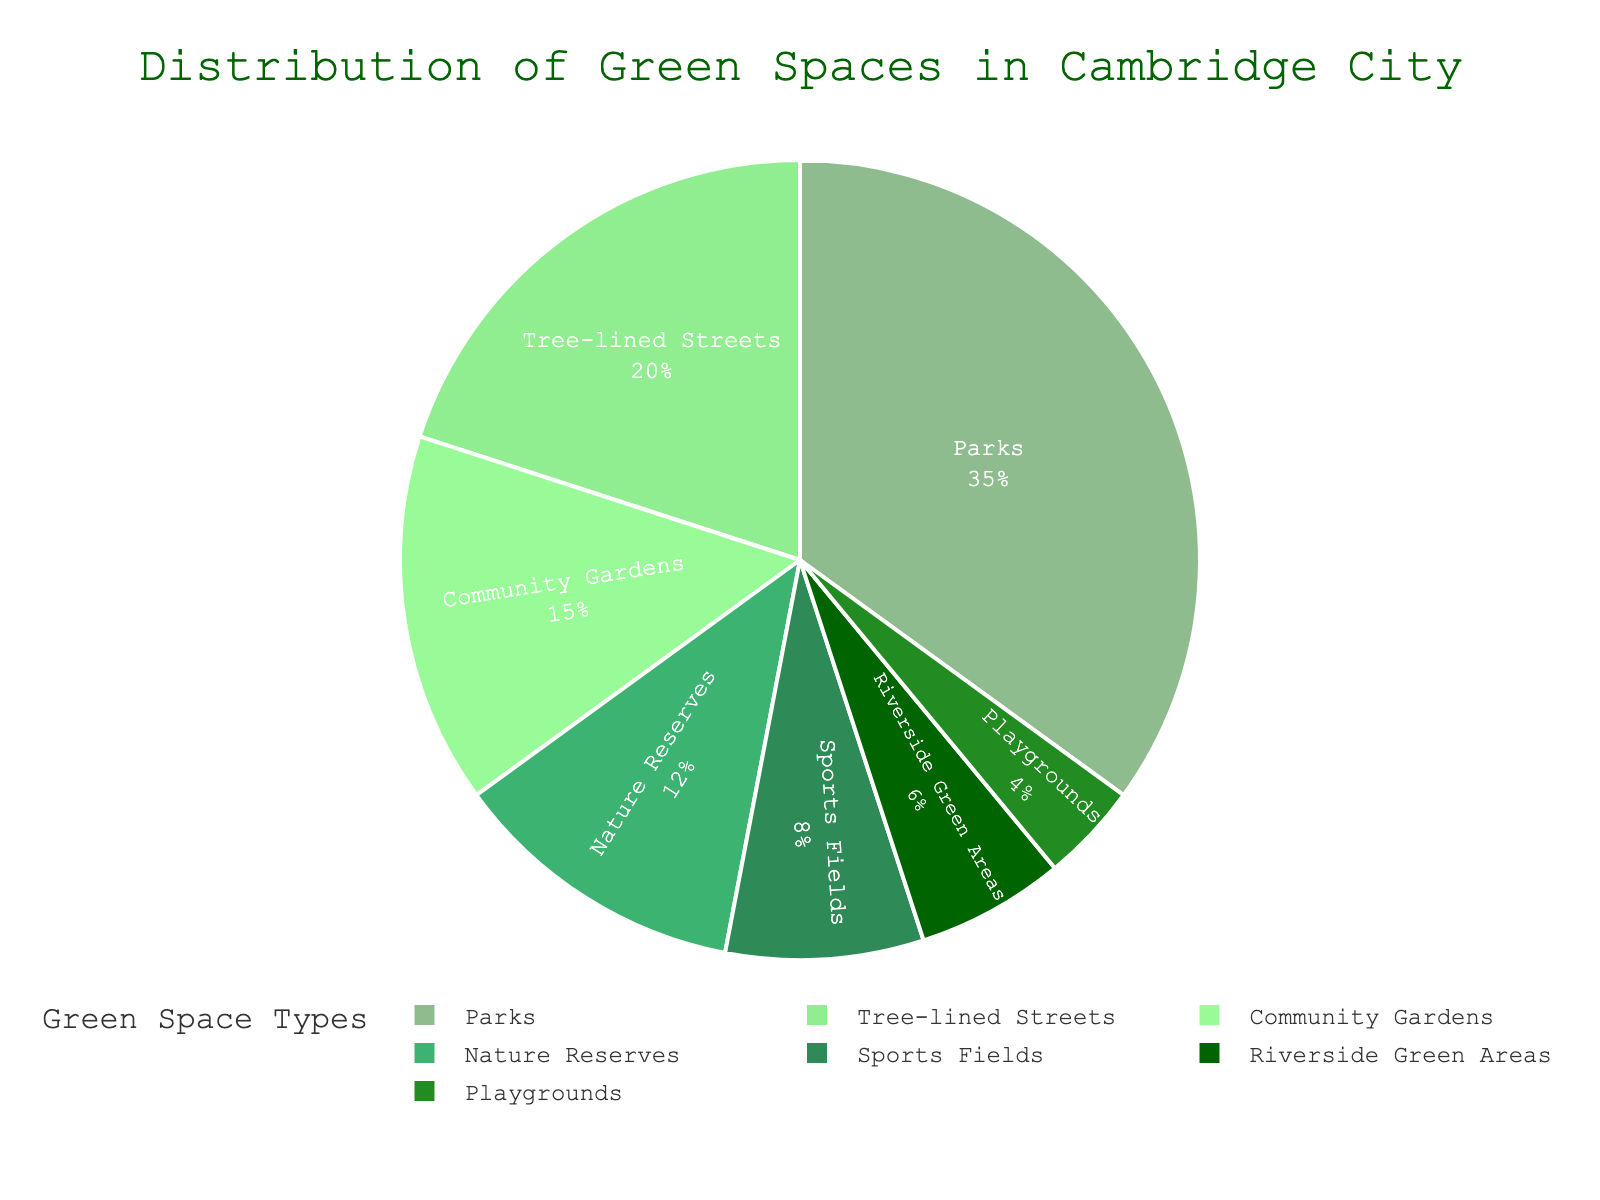What type of green space occupies the largest percentage in Cambridge City? The type that occupies the largest percentage is the one with the highest value in the pie chart. From the data, Parks occupy 35%, which is the largest.
Answer: Parks Which green space type has a higher percentage, sports fields or playgrounds? Compare the percentages of sports fields and playgrounds. Sports fields occupy 8%, while playgrounds occupy 4%. Since 8% is greater than 4%, sports fields have a higher percentage.
Answer: Sports fields Are community gardens and nature reserves collectively occupying more or less than 30%? Add the percentages of community gardens (15%) and nature reserves (12%) to get the total. 15% + 12% = 27%, which is less than 30%.
Answer: Less How much larger is the percentage of tree-lined streets compared to riverside green areas? Subtract the percentage of riverside green areas (6%) from the percentage of tree-lined streets (20%). 20% - 6% = 14%.
Answer: 14% What percentage of green spaces is dedicated to playgrounds and riverside green areas combined? Add the percentages of playgrounds (4%) and riverside green areas (6%). 4% + 6% = 10%.
Answer: 10% Which category occupies the third-largest percentage of green spaces in Cambridge City? List the percentages in descending order: Parks (35%), Tree-lined Streets (20%), Community Gardens (15%), Nature Reserves (12%), etc. The third-largest percentage is for Community Gardens at 15%.
Answer: Community Gardens Do sports fields and nature reserves together occupy a higher percentage than parks? Add the percentages of sports fields (8%) and nature reserves (12%), which gives 8% + 12% = 20%. Compare this to the percentage of parks (35%). Since 20% is less than 35%, they occupy a lower percentage than parks.
Answer: No How many types of green spaces occupy 10% or more individually? Identify the types with percentages 10% or more: Parks (35%), Community Gardens (15%), Tree-lined Streets (20%), and Nature Reserves (12%). Count them to get the total: 4 types.
Answer: 4 What color is used to represent community gardens in the chart? Identify the color associated with community gardens. According to the color palette provided, community gardens are represented by the second color, '#90EE90', which is a shade of light green.
Answer: Light green How does the combined percentage of parks and tree-lined streets compare to half of the total green spaces? Add the percentages of parks (35%) and tree-lined streets (20%) to get 55%. Half of the total green spaces is 50%. Since 55% is greater than 50%, the combined percentage is more than half.
Answer: More 